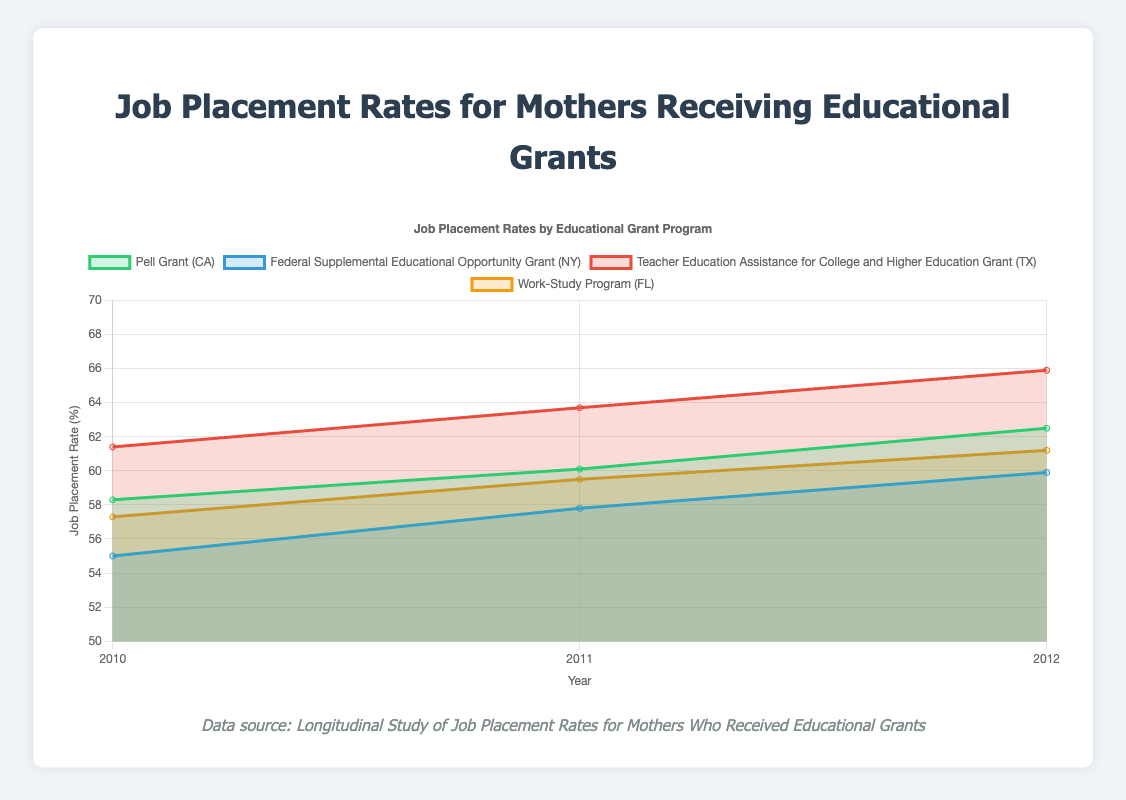What is the overall trend observed in the job placement rates for Pell Grant recipients in California from 2010 to 2012? The data points for Pell Grant recipients in California show an increase in job placement rates from 58.3% in 2010 to 62.5% in 2012. Visual inspection indicates a steady upward trend indicating improvement over the years.
Answer: Increasing Between the year 2010 and 2011, which program showed the highest increase in job placement rate? By examining the difference in job placement rates for each program from 2010 to 2011, the Teacher Education Assistance for College and Higher Education Grant (TX) showed the highest increase from 61.4% to 63.7%, indicating a 2.3% increase.
Answer: Teacher Education Assistance for College and Higher Education Grant (TX) How do the job placement rates for the Federal Supplemental Educational Opportunity Grant (NY) compare to the Work-Study Program (FL) over the years? In 2010, the job placement rate for the Federal Supplemental Educational Opportunity Grant (NY) is 55.0%, which is lower than the Work-Study Program (FL) at 57.3%. In 2011 and 2012, this pattern persists with job placement rates of 57.8% (NY) vs. 59.5% (FL) and 59.9% (NY) vs. 61.2% (FL), respectively.
Answer: Work-Study Program (FL) has higher rates each year Which program consistently had the highest job placement rates from 2010 to 2012, and what were those rates? The Teacher Education Assistance for College and Higher Education Grant (TX) consistently had the highest job placement rates across the years, with 61.4% in 2010, 63.7% in 2011, and 65.9% in 2012.
Answer: Teacher Education Assistance for College and Higher Education Grant (TX); 61.4%, 63.7%, 65.9% Among the programs listed, which program showed the lowest job placement rate at any point between 2010 and 2012, and what was the rate? The lowest job placement rate observed across the programs is for the Federal Supplemental Educational Opportunity Grant (NY), which had a rate of 55.0% in 2010.
Answer: Federal Supplemental Educational Opportunity Grant (NY); 55.0% What is the average job placement rate for Pell Grant recipients in California over the three years? The job placement rates for Pell Grant recipients in California are 58.3% in 2010, 60.1% in 2011, and 62.5% in 2012. The sum is 180.9%. Dividing by three years gives an average rate of 60.3%.
Answer: 60.3% If we combine the total participants for all programs in 2012, what is the total number? Adding the total participants for Pell Grant (1300), Federal Supplemental Educational Opportunity Grant (1200), Teacher Education Assistance for College and Higher Education Grant (1000), and Work-Study Program (1150) in 2012 gives us 4650 participants.
Answer: 4650 